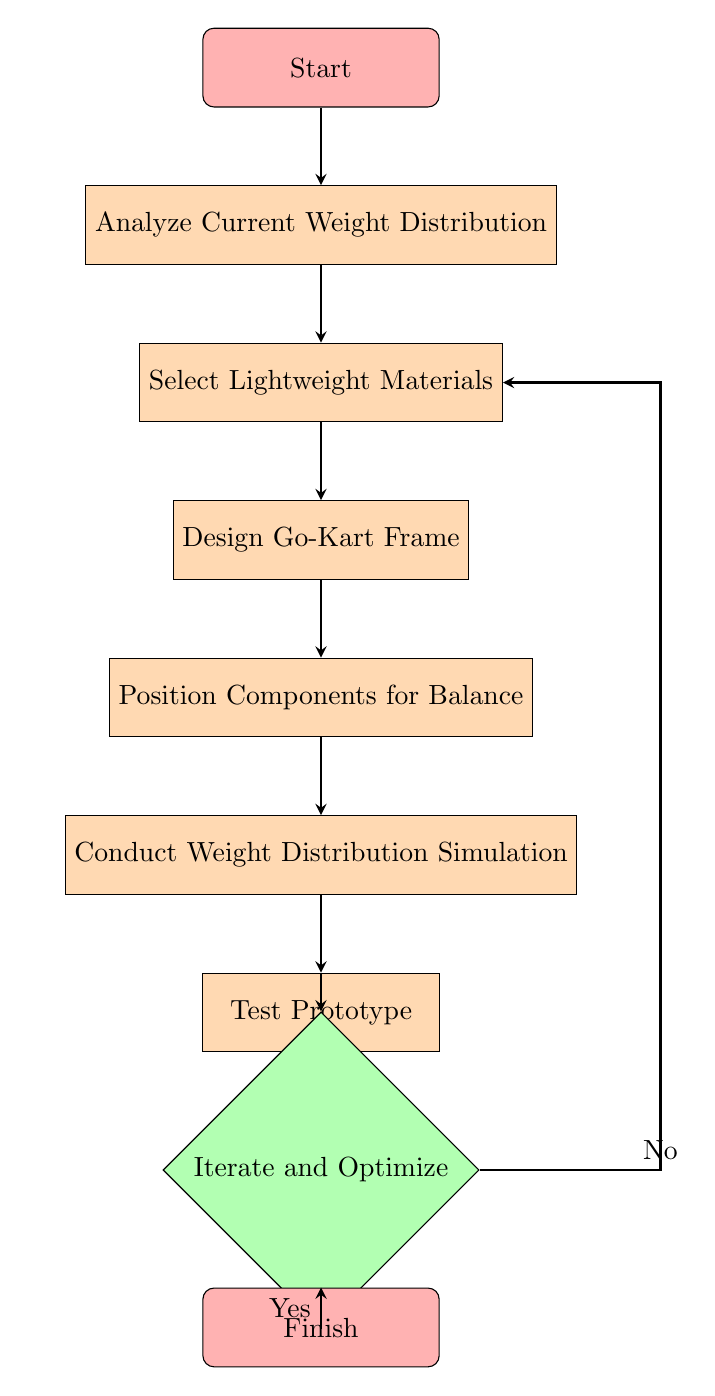What is the first step in the flow chart? The first step in the flow chart is labeled "Start", which indicates the initiation of the process.
Answer: Start How many nodes are present in the diagram? By counting the labeled nodes from "Start" to "Finish", there are a total of eight nodes in the diagram.
Answer: Eight What is the final action listed in the flow chart? The final action in the flow chart is "Finish", which signifies the completion of the optimization process.
Answer: Finish What follows the "Test Prototype" step? The step immediately following "Test Prototype" is "Iterate and Optimize", which involves making adjustments based on the testing results.
Answer: Iterate and Optimize Which materials are suggested for selection? The materials suggested for selection include Carbon Fiber, Aluminum Alloys, and Titanium, each known for their lightweight and robust properties.
Answer: Carbon Fiber, Aluminum Alloys, Titanium What is the relationship between "Conduct Weight Distribution Simulation" and "Test Prototype"? "Conduct Weight Distribution Simulation" is a prerequisite that must be completed before proceeding to "Test Prototype", indicating a sequential process in the optimization.
Answer: Sequential process What considerations are taken when designing the Go-Kart frame? When designing the Go-Kart frame, considerations include optimizing for stiffness and flexibility, as well as minimizing material usage in the design.
Answer: Optimize for stiffness and flexibility, Minimize material usage What tools are mentioned for conducting simulations? The tools mentioned for conducting simulations are Finite Element Analysis (FEA) and Multibody Dynamics (MBD) Software, which are essential for evaluating weight distribution.
Answer: Finite Element Analysis, Multibody Dynamics Software How does the process return to material selection? If the iteration in "Iterate and Optimize" determines additional adjustments are needed (indicated by "No"), the process returns to "Select Lightweight Materials" to reassess material options.
Answer: Returns to "Select Lightweight Materials" 